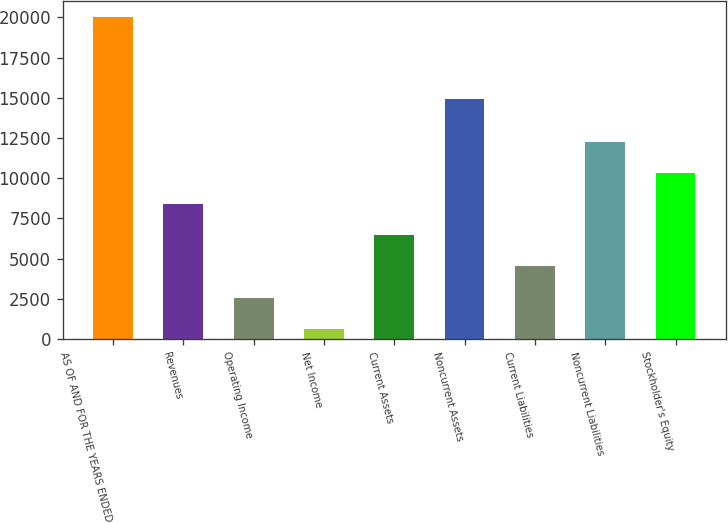<chart> <loc_0><loc_0><loc_500><loc_500><bar_chart><fcel>AS OF AND FOR THE YEARS ENDED<fcel>Revenues<fcel>Operating Income<fcel>Net Income<fcel>Current Assets<fcel>Noncurrent Assets<fcel>Current Liabilities<fcel>Noncurrent Liabilities<fcel>Stockholder's Equity<nl><fcel>20011<fcel>8394.4<fcel>2586.1<fcel>650<fcel>6458.3<fcel>14942<fcel>4522.2<fcel>12266.6<fcel>10330.5<nl></chart> 